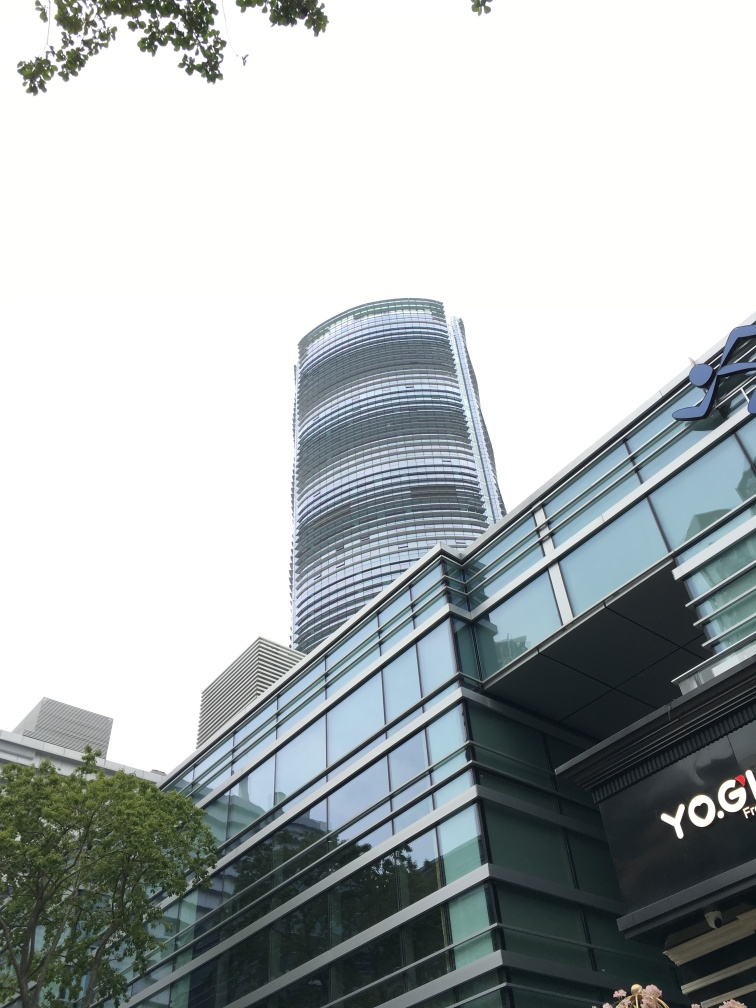Is the foreground sharp? Based on the image, the foreground which includes elements like the trees and the building facade, appears to be reasonably sharp, with clear and defined edges visible. However, the slight variation in the clarity amongst the closest elements could lead to mixed interpretations of 'sharpness'. The sky, however, is over-exposed, which might affect the perception of overall sharpness. 